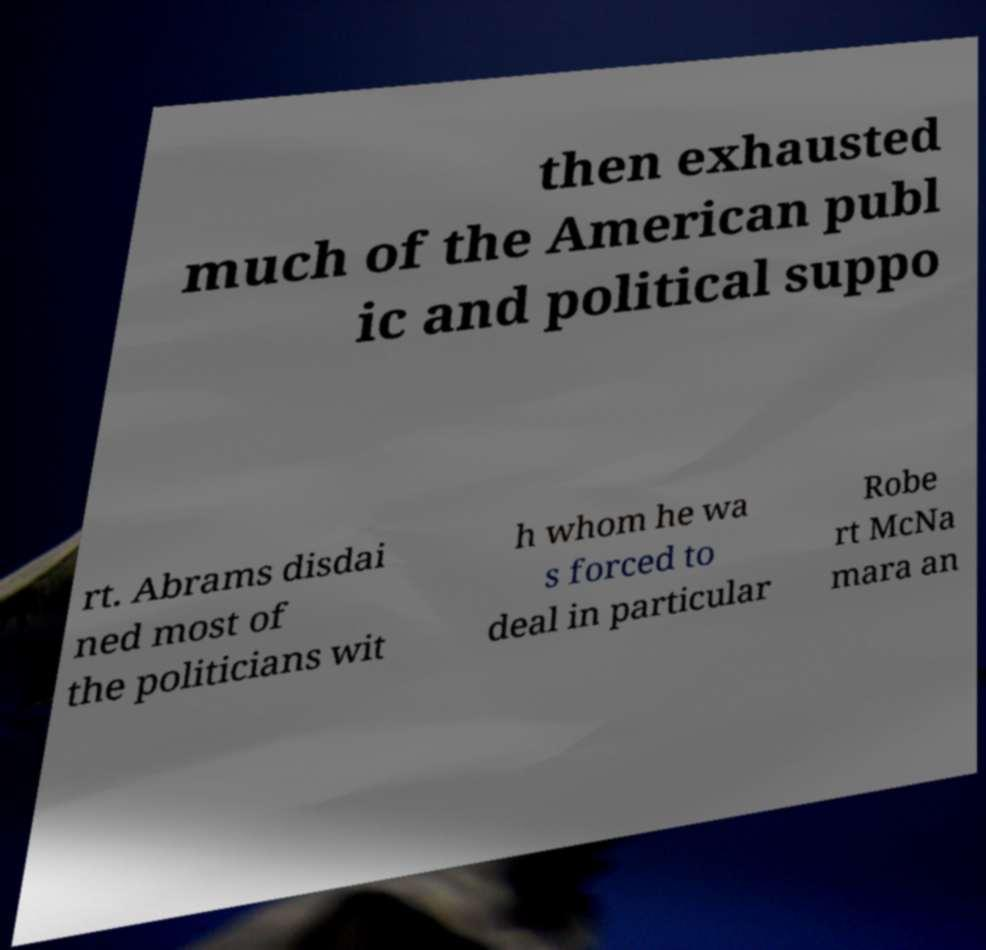Please read and relay the text visible in this image. What does it say? then exhausted much of the American publ ic and political suppo rt. Abrams disdai ned most of the politicians wit h whom he wa s forced to deal in particular Robe rt McNa mara an 